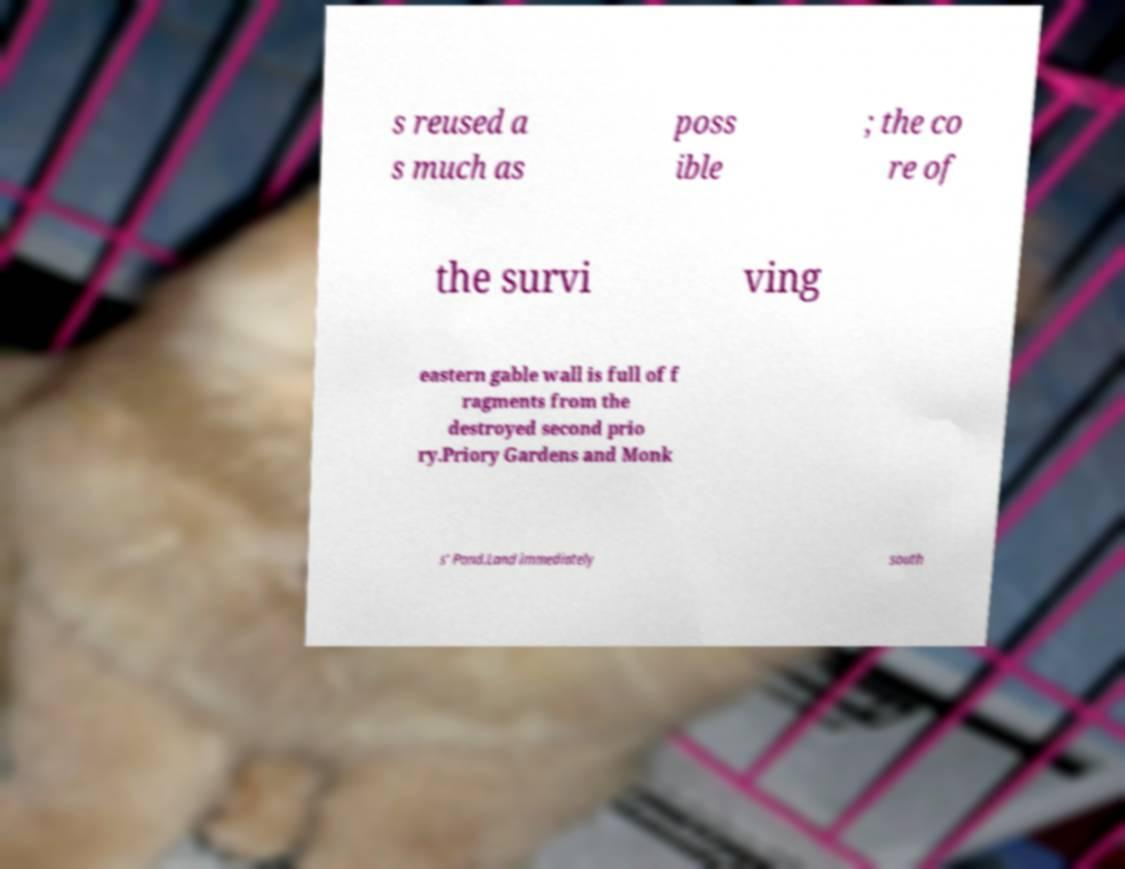Can you read and provide the text displayed in the image?This photo seems to have some interesting text. Can you extract and type it out for me? s reused a s much as poss ible ; the co re of the survi ving eastern gable wall is full of f ragments from the destroyed second prio ry.Priory Gardens and Monk s' Pond.Land immediately south 